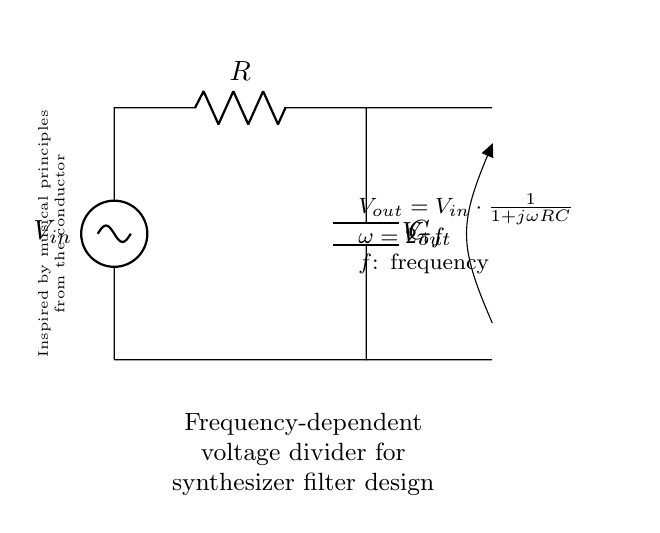What is the input voltage in the circuit? The input voltage is denoted as \( V_{in} \), which is shown in the circuit diagram at the top left corner.
Answer: \( V_{in} \) What components are used in this circuit? The circuit uses a resistor labeled \( R \) and a capacitor labeled \( C \), as indicated in the diagram.
Answer: Resistor and Capacitor What is the expression for \( V_{out} \)? The output voltage \( V_{out} \) is expressed as \( V_{in} \cdot \frac{1}{1 + j\omega RC} \), which is displayed on the right side of the circuit.
Answer: \( V_{in} \cdot \frac{1}{1 + j\omega RC} \) How does the output voltage change with frequency? The relationship shows that as frequency increases, \( \omega \) increases, affecting \( V_{out} \) due to the denominator \( 1 + j\omega RC \), which causes \( V_{out} \) to decrease. This indicates that the output is frequency-dependent.
Answer: Decreases with increasing frequency What is the role of the capacitor in this circuit? The capacitor provides frequency-dependent behavior by allowing higher frequencies to pass through while attenuating lower frequencies, contributing to the filter characteristics of the circuit.
Answer: Filters frequencies At which frequency is the output voltage equal to \( V_{in} \)? The output voltage is equal to \( V_{in} \) when the frequency is zero because in this case, \( j\omega RC \) becomes zero resulting in \( V_{out} = V_{in} \).
Answer: Zero frequency What is the significance of \( j \) in the expression for \( V_{out} \)? The \( j \) represents the imaginary unit and indicates that the circuit's response is complex, involving both resistive and reactive (capacitive) components, which is crucial for understanding the phase shifts in AC signals.
Answer: Indicates complex impedance 